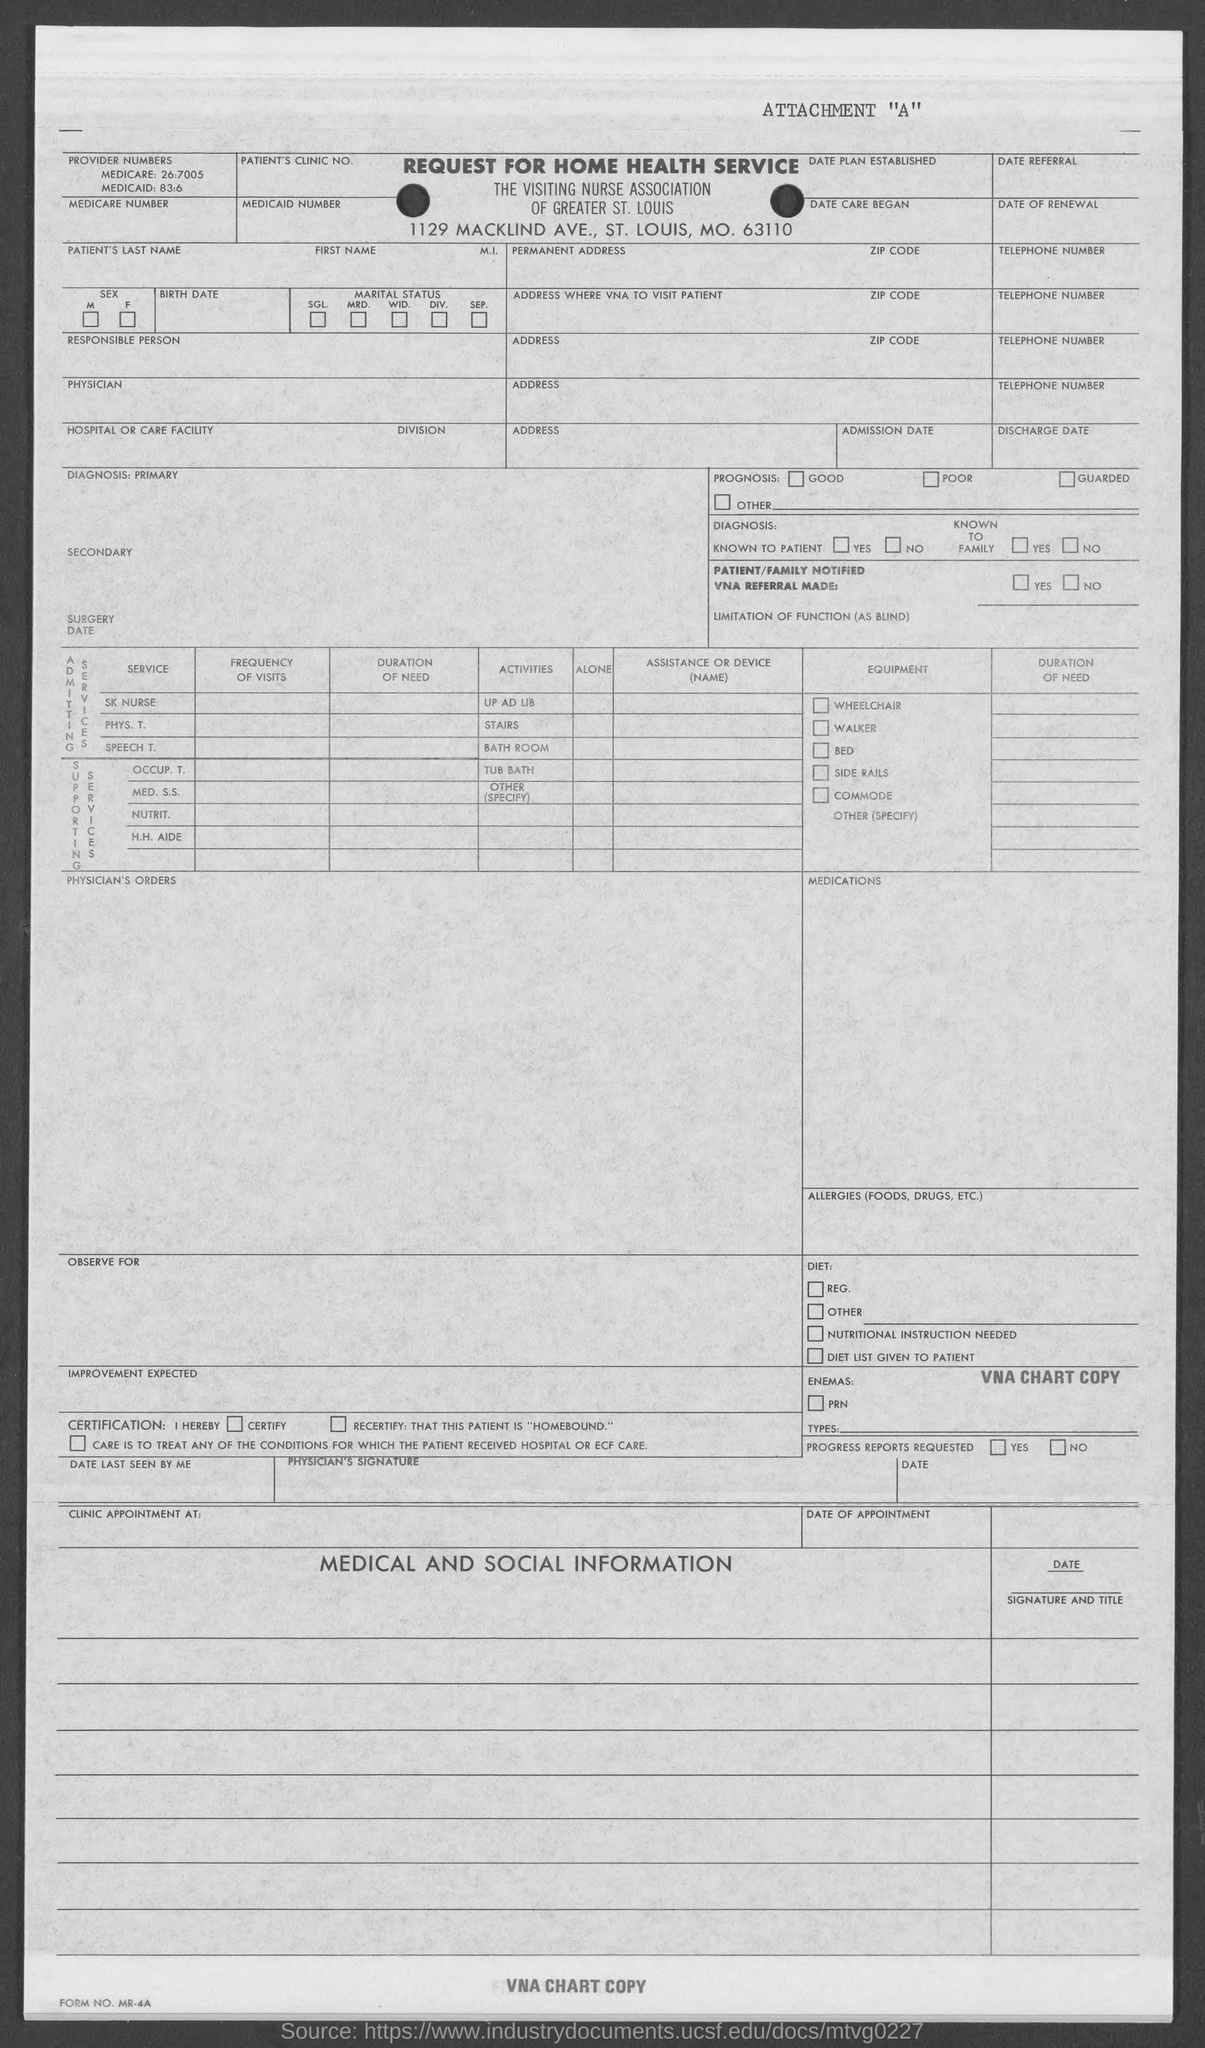What type of form is given here?
Your response must be concise. REQUEST FOR HOME HEALTH SERVICE. 